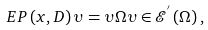<formula> <loc_0><loc_0><loc_500><loc_500>E P \left ( x , D \right ) \upsilon = \upsilon \Omega \upsilon \in \mathcal { E } ^ { ^ { \prime } } \left ( \Omega \right ) ,</formula> 